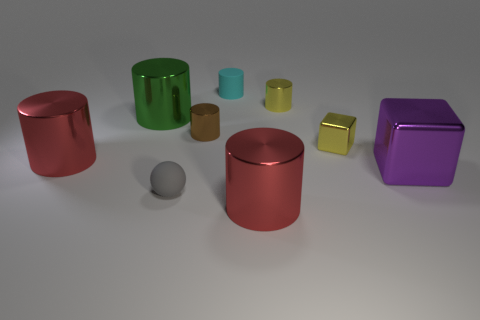How does the size of the metallic spheres compare to the other objects? The metallic spheres in the image vary in size; the grey one is much smaller compared to any other object, while the larger red sphere is comparative in size to the cylinders. 